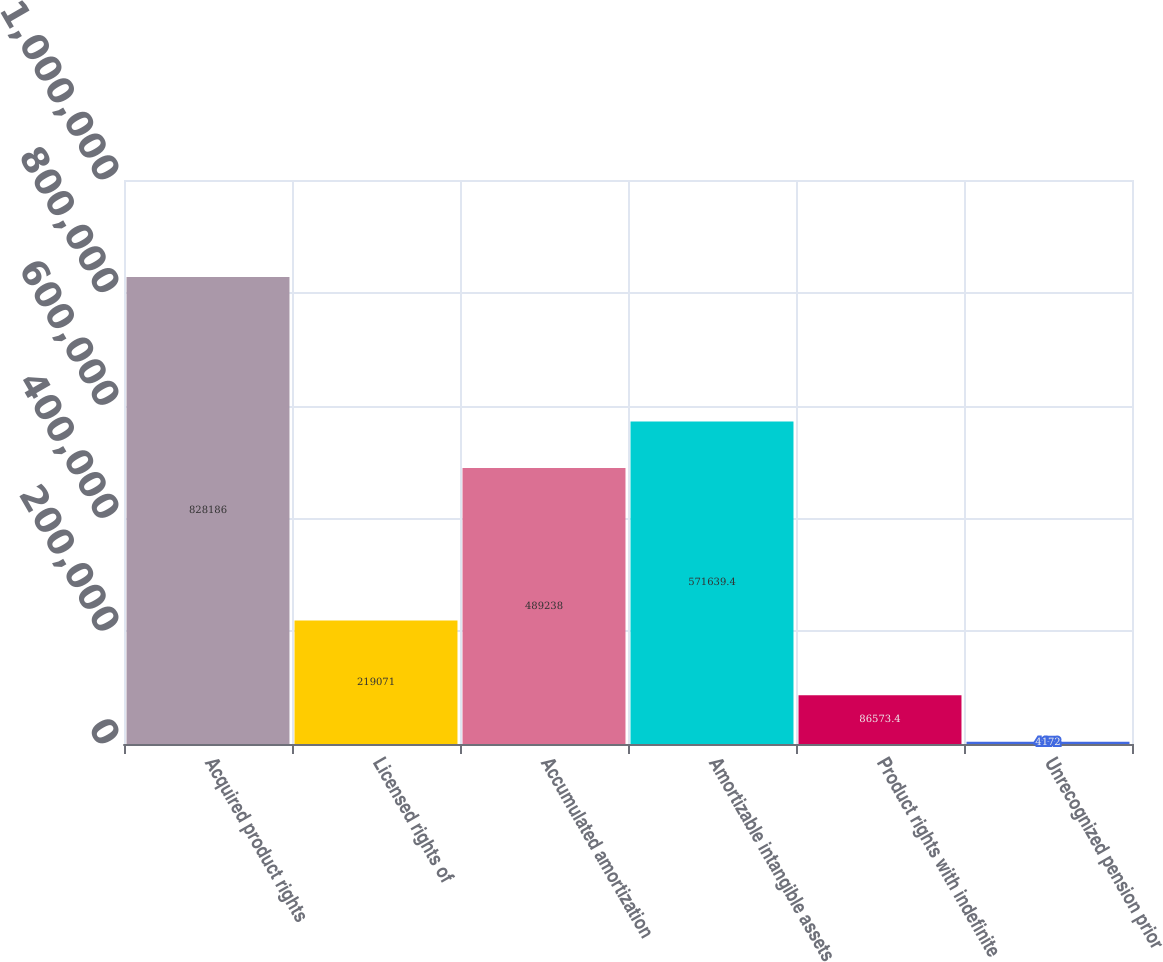Convert chart to OTSL. <chart><loc_0><loc_0><loc_500><loc_500><bar_chart><fcel>Acquired product rights<fcel>Licensed rights of<fcel>Accumulated amortization<fcel>Amortizable intangible assets<fcel>Product rights with indefinite<fcel>Unrecognized pension prior<nl><fcel>828186<fcel>219071<fcel>489238<fcel>571639<fcel>86573.4<fcel>4172<nl></chart> 